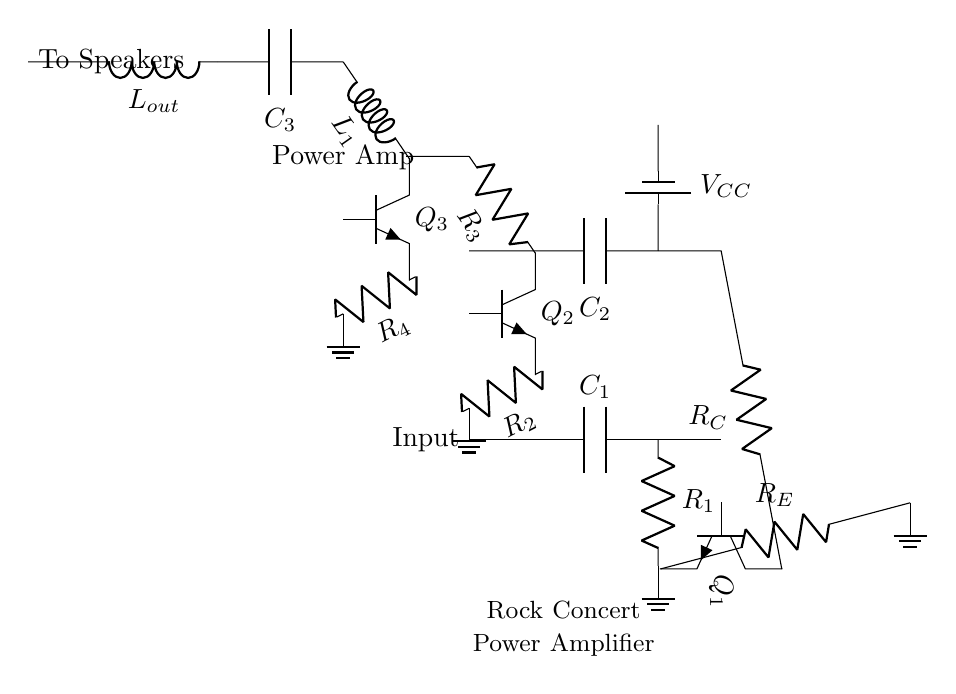What is the purpose of C1? C1 is a coupling capacitor that allows AC signals to pass while blocking DC components, providing a path for the input signal to reach the next stage without affecting the biasing of the circuit.
Answer: Coupling capacitor What type of transistor is Q3? Q3 is an NPN transistor used for amplification in this circuit. It is part of the power amplifier stage, which boosts the signal for driving large speakers.
Answer: NPN transistor How many resistors are in the circuit? There are four resistors labeled R1, R2, R3, and R4, which are used for biasing and gain determinations in various stages of the amplifier.
Answer: Four What component connects the output to the speakers? The output connects to the speakers through an inductor labeled Lout, which helps in filtering and delivering the amplified signal to the speakers.
Answer: Inductor What is the supply voltage for the amplifier? The supply voltage is indicated as VCC, which typically provides the necessary voltage for the circuit's operation, though the exact value is not specified in the diagram.
Answer: VCC What is the function of R_E? R_E is the emitter resistor, which stabilizes the operation of the transistor by providing temperature stability and controlling the gain of the amplifier in the pre-amplifier stage.
Answer: Emitter resistor Which component is used for filtering at the output? The component used for filtering at the output is the capacitor labeled C3, which smoothens the output signal before it is sent to the speakers.
Answer: Capacitor 